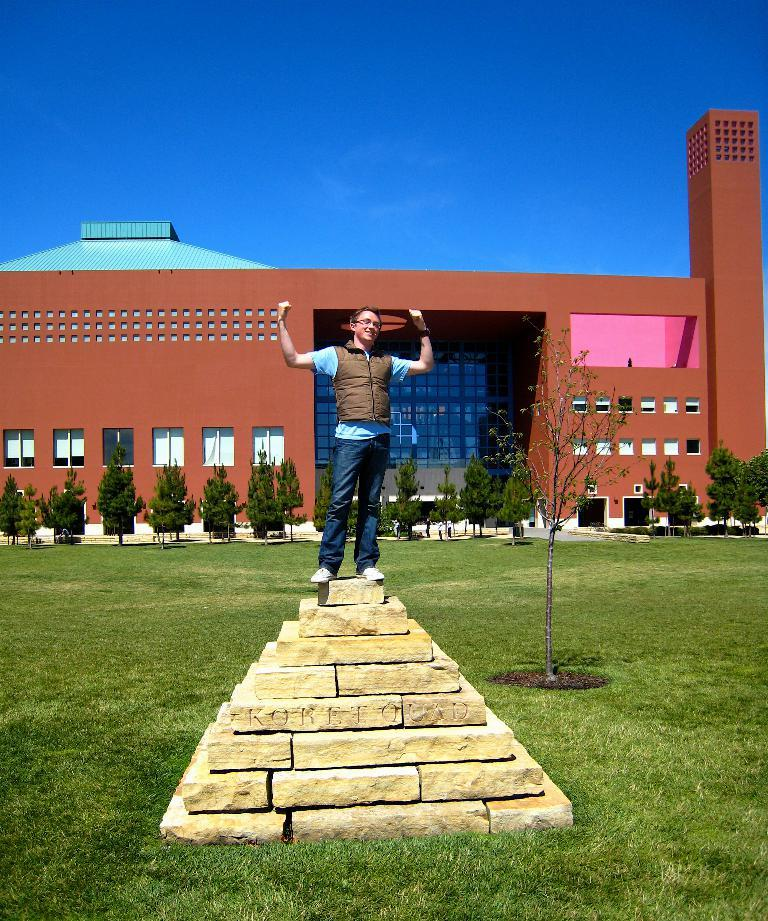What is the man doing in the image? The man is standing on a pyramid in the image. What is the pyramid standing on? The pyramid is on the grass in the image. What can be seen in the background of the image? There are trees and a building visible in the background of the image. How many feet are visible on the man in the image? The image does not show the man's feet, so it is impossible to determine how many feet are visible. 